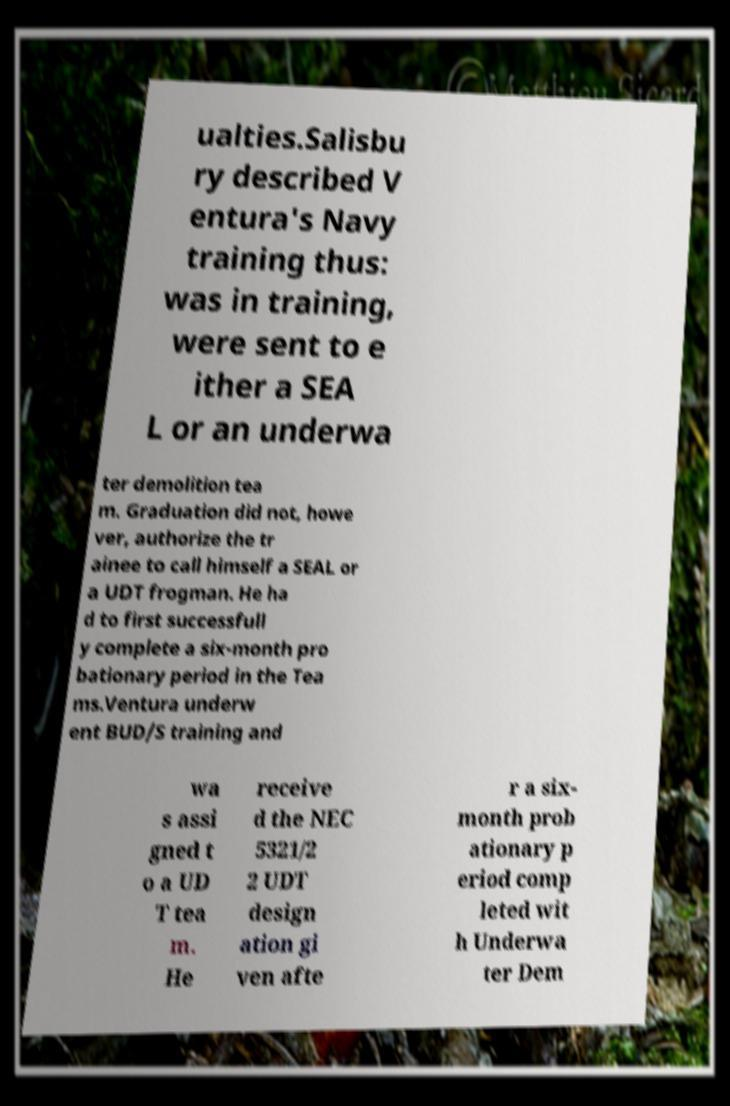Please read and relay the text visible in this image. What does it say? ualties.Salisbu ry described V entura's Navy training thus: was in training, were sent to e ither a SEA L or an underwa ter demolition tea m. Graduation did not, howe ver, authorize the tr ainee to call himself a SEAL or a UDT frogman. He ha d to first successfull y complete a six-month pro bationary period in the Tea ms.Ventura underw ent BUD/S training and wa s assi gned t o a UD T tea m. He receive d the NEC 5321/2 2 UDT design ation gi ven afte r a six- month prob ationary p eriod comp leted wit h Underwa ter Dem 